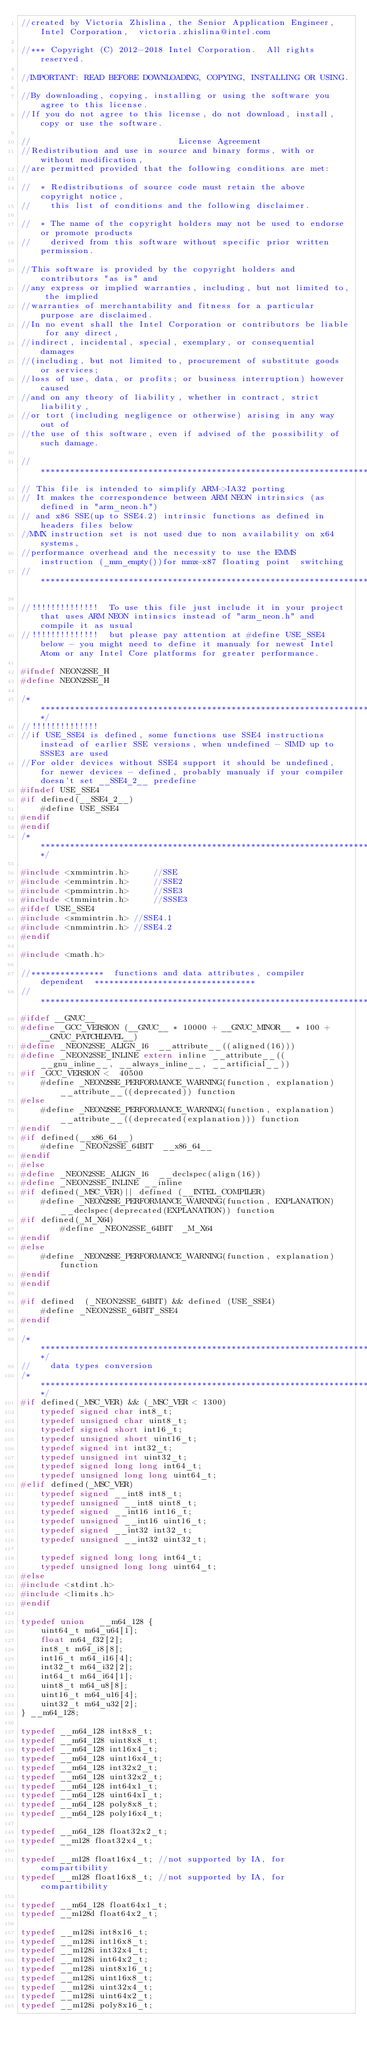<code> <loc_0><loc_0><loc_500><loc_500><_C_>//created by Victoria Zhislina, the Senior Application Engineer, Intel Corporation,  victoria.zhislina@intel.com

//*** Copyright (C) 2012-2018 Intel Corporation.  All rights reserved.

//IMPORTANT: READ BEFORE DOWNLOADING, COPYING, INSTALLING OR USING.

//By downloading, copying, installing or using the software you agree to this license.
//If you do not agree to this license, do not download, install, copy or use the software.

//                              License Agreement
//Redistribution and use in source and binary forms, with or without modification,
//are permitted provided that the following conditions are met:

//  * Redistributions of source code must retain the above copyright notice,
//    this list of conditions and the following disclaimer.

//  * The name of the copyright holders may not be used to endorse or promote products
//    derived from this software without specific prior written permission.

//This software is provided by the copyright holders and contributors "as is" and
//any express or implied warranties, including, but not limited to, the implied
//warranties of merchantability and fitness for a particular purpose are disclaimed.
//In no event shall the Intel Corporation or contributors be liable for any direct,
//indirect, incidental, special, exemplary, or consequential damages
//(including, but not limited to, procurement of substitute goods or services;
//loss of use, data, or profits; or business interruption) however caused
//and on any theory of liability, whether in contract, strict liability,
//or tort (including negligence or otherwise) arising in any way out of
//the use of this software, even if advised of the possibility of such damage.

//*****************************************************************************************
// This file is intended to simplify ARM->IA32 porting
// It makes the correspondence between ARM NEON intrinsics (as defined in "arm_neon.h")
// and x86 SSE(up to SSE4.2) intrinsic functions as defined in headers files below
//MMX instruction set is not used due to non availability on x64 systems,
//performance overhead and the necessity to use the EMMS instruction (_mm_empty())for mmx-x87 floating point  switching
//*****************************************************************************************

//!!!!!!!!!!!!!!  To use this file just include it in your project that uses ARM NEON intinsics instead of "arm_neon.h" and compile it as usual
//!!!!!!!!!!!!!!  but please pay attention at #define USE_SSE4 below - you might need to define it manualy for newest Intel Atom or any Intel Core platforms for greater performance.

#ifndef NEON2SSE_H
#define NEON2SSE_H

/*********************************************************************************************************************/
//!!!!!!!!!!!!!! 
//if USE_SSE4 is defined, some functions use SSE4 instructions instead of earlier SSE versions, when undefined - SIMD up to SSSE3 are used
//For older devices without SSE4 support it should be undefined,  for newer devices - defined, probably manualy if your compiler doesn't set __SSE4_2__ predefine
#ifndef USE_SSE4
#if defined(__SSE4_2__)
    #define USE_SSE4
#endif
#endif
/*********************************************************************************************************************/

#include <xmmintrin.h>     //SSE
#include <emmintrin.h>     //SSE2
#include <pmmintrin.h>     //SSE3
#include <tmmintrin.h>     //SSSE3
#ifdef USE_SSE4
#include <smmintrin.h> //SSE4.1
#include <nmmintrin.h> //SSE4.2
#endif

#include <math.h>

//***************  functions and data attributes, compiler dependent  *********************************
//***********************************************************************************
#ifdef __GNUC__
#define _GCC_VERSION (__GNUC__ * 10000 + __GNUC_MINOR__ * 100 + __GNUC_PATCHLEVEL__)
#define _NEON2SSE_ALIGN_16  __attribute__((aligned(16)))
#define _NEON2SSE_INLINE extern inline __attribute__((__gnu_inline__, __always_inline__, __artificial__))
#if _GCC_VERSION <  40500
    #define _NEON2SSE_PERFORMANCE_WARNING(function, explanation)   __attribute__((deprecated)) function
#else
    #define _NEON2SSE_PERFORMANCE_WARNING(function, explanation)   __attribute__((deprecated(explanation))) function
#endif
#if defined(__x86_64__)
    #define _NEON2SSE_64BIT  __x86_64__
#endif
#else
#define _NEON2SSE_ALIGN_16  __declspec(align(16))
#define _NEON2SSE_INLINE __inline
#if defined(_MSC_VER)|| defined (__INTEL_COMPILER)  
    #define _NEON2SSE_PERFORMANCE_WARNING(function, EXPLANATION) __declspec(deprecated(EXPLANATION)) function
#if defined(_M_X64)
        #define _NEON2SSE_64BIT  _M_X64
#endif
#else
    #define _NEON2SSE_PERFORMANCE_WARNING(function, explanation)  function
#endif
#endif

#if defined  (_NEON2SSE_64BIT) && defined (USE_SSE4)
    #define _NEON2SSE_64BIT_SSE4
#endif

/*********************************************************************************************************************/
//    data types conversion
/*********************************************************************************************************************/
#if defined(_MSC_VER) && (_MSC_VER < 1300)
    typedef signed char int8_t;
    typedef unsigned char uint8_t;
    typedef signed short int16_t;
    typedef unsigned short uint16_t;
    typedef signed int int32_t;
    typedef unsigned int uint32_t;
    typedef signed long long int64_t;
    typedef unsigned long long uint64_t;
#elif defined(_MSC_VER)
    typedef signed __int8 int8_t;
    typedef unsigned __int8 uint8_t;
    typedef signed __int16 int16_t;
    typedef unsigned __int16 uint16_t;
    typedef signed __int32 int32_t;
    typedef unsigned __int32 uint32_t;

    typedef signed long long int64_t;
    typedef unsigned long long uint64_t;
#else
#include <stdint.h>
#include <limits.h>
#endif

typedef union   __m64_128 {
    uint64_t m64_u64[1];
    float m64_f32[2];
    int8_t m64_i8[8];
    int16_t m64_i16[4];
    int32_t m64_i32[2];
    int64_t m64_i64[1];
    uint8_t m64_u8[8];
    uint16_t m64_u16[4];
    uint32_t m64_u32[2];
} __m64_128;

typedef __m64_128 int8x8_t;
typedef __m64_128 uint8x8_t;
typedef __m64_128 int16x4_t;
typedef __m64_128 uint16x4_t;
typedef __m64_128 int32x2_t;
typedef __m64_128 uint32x2_t;
typedef __m64_128 int64x1_t;
typedef __m64_128 uint64x1_t;
typedef __m64_128 poly8x8_t;
typedef __m64_128 poly16x4_t;

typedef __m64_128 float32x2_t;
typedef __m128 float32x4_t;

typedef __m128 float16x4_t; //not supported by IA, for compartibility
typedef __m128 float16x8_t; //not supported by IA, for compartibility

typedef __m64_128 float64x1_t;
typedef __m128d float64x2_t;

typedef __m128i int8x16_t;
typedef __m128i int16x8_t;
typedef __m128i int32x4_t;
typedef __m128i int64x2_t;
typedef __m128i uint8x16_t;
typedef __m128i uint16x8_t;
typedef __m128i uint32x4_t;
typedef __m128i uint64x2_t;
typedef __m128i poly8x16_t;</code> 